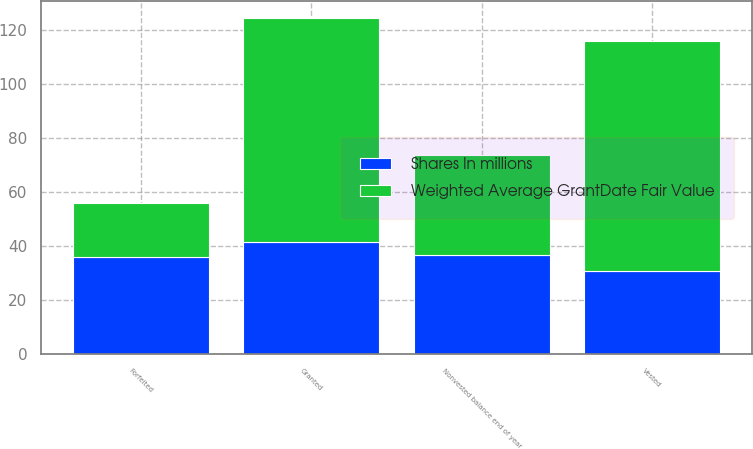<chart> <loc_0><loc_0><loc_500><loc_500><stacked_bar_chart><ecel><fcel>Granted<fcel>Vested<fcel>Forfeited<fcel>Nonvested balance end of year<nl><fcel>Weighted Average GrantDate Fair Value<fcel>83<fcel>85<fcel>20<fcel>36.92<nl><fcel>Shares In millions<fcel>41.51<fcel>30.98<fcel>35.93<fcel>36.92<nl></chart> 